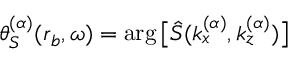<formula> <loc_0><loc_0><loc_500><loc_500>\theta _ { S } ^ { ( \alpha ) } ( r _ { b } , \omega ) = \arg \left [ \hat { S } ( k _ { x } ^ { ( \alpha ) } , k _ { z } ^ { ( \alpha ) } ) \right ]</formula> 